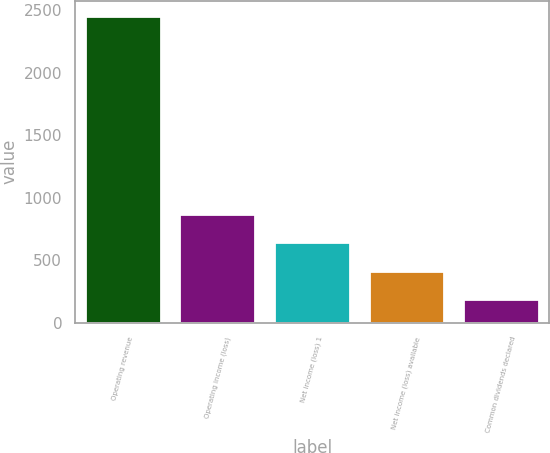Convert chart to OTSL. <chart><loc_0><loc_0><loc_500><loc_500><bar_chart><fcel>Operating revenue<fcel>Operating income (loss)<fcel>Net income (loss) 1<fcel>Net income (loss) available<fcel>Common dividends declared<nl><fcel>2456<fcel>870.5<fcel>644<fcel>417.5<fcel>191<nl></chart> 